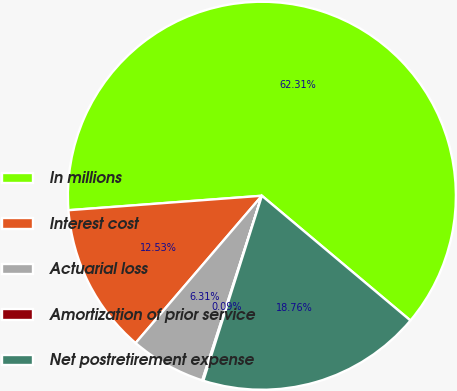Convert chart. <chart><loc_0><loc_0><loc_500><loc_500><pie_chart><fcel>In millions<fcel>Interest cost<fcel>Actuarial loss<fcel>Amortization of prior service<fcel>Net postretirement expense<nl><fcel>62.3%<fcel>12.53%<fcel>6.31%<fcel>0.09%<fcel>18.76%<nl></chart> 